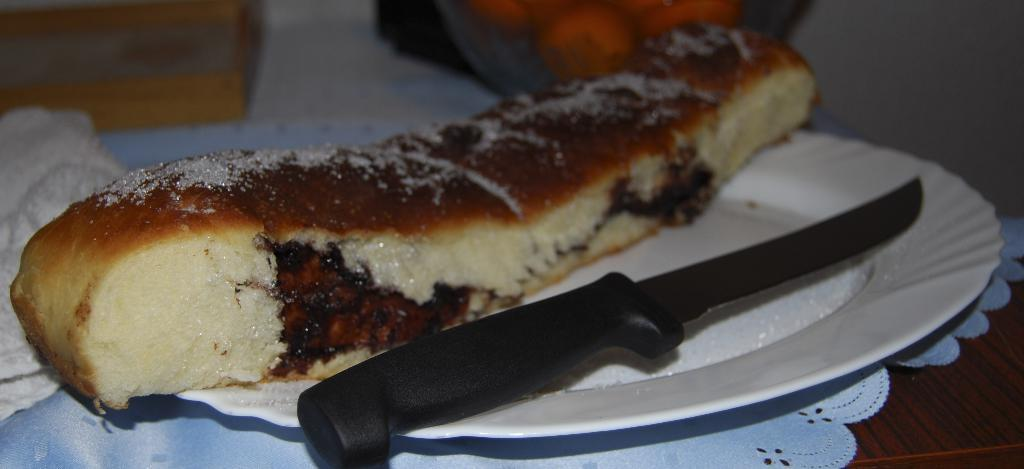What is on the plate in the image? There is a knife and food on the plate in the image. What type of surface is the white cloth placed on? The white cloth is placed on a wooden surface. What can be seen in the background of the image? There are objects visible in the background of the image. What type of fuel is being used by the insect in the image? There is no insect present in the image, so there is no fuel being used. 